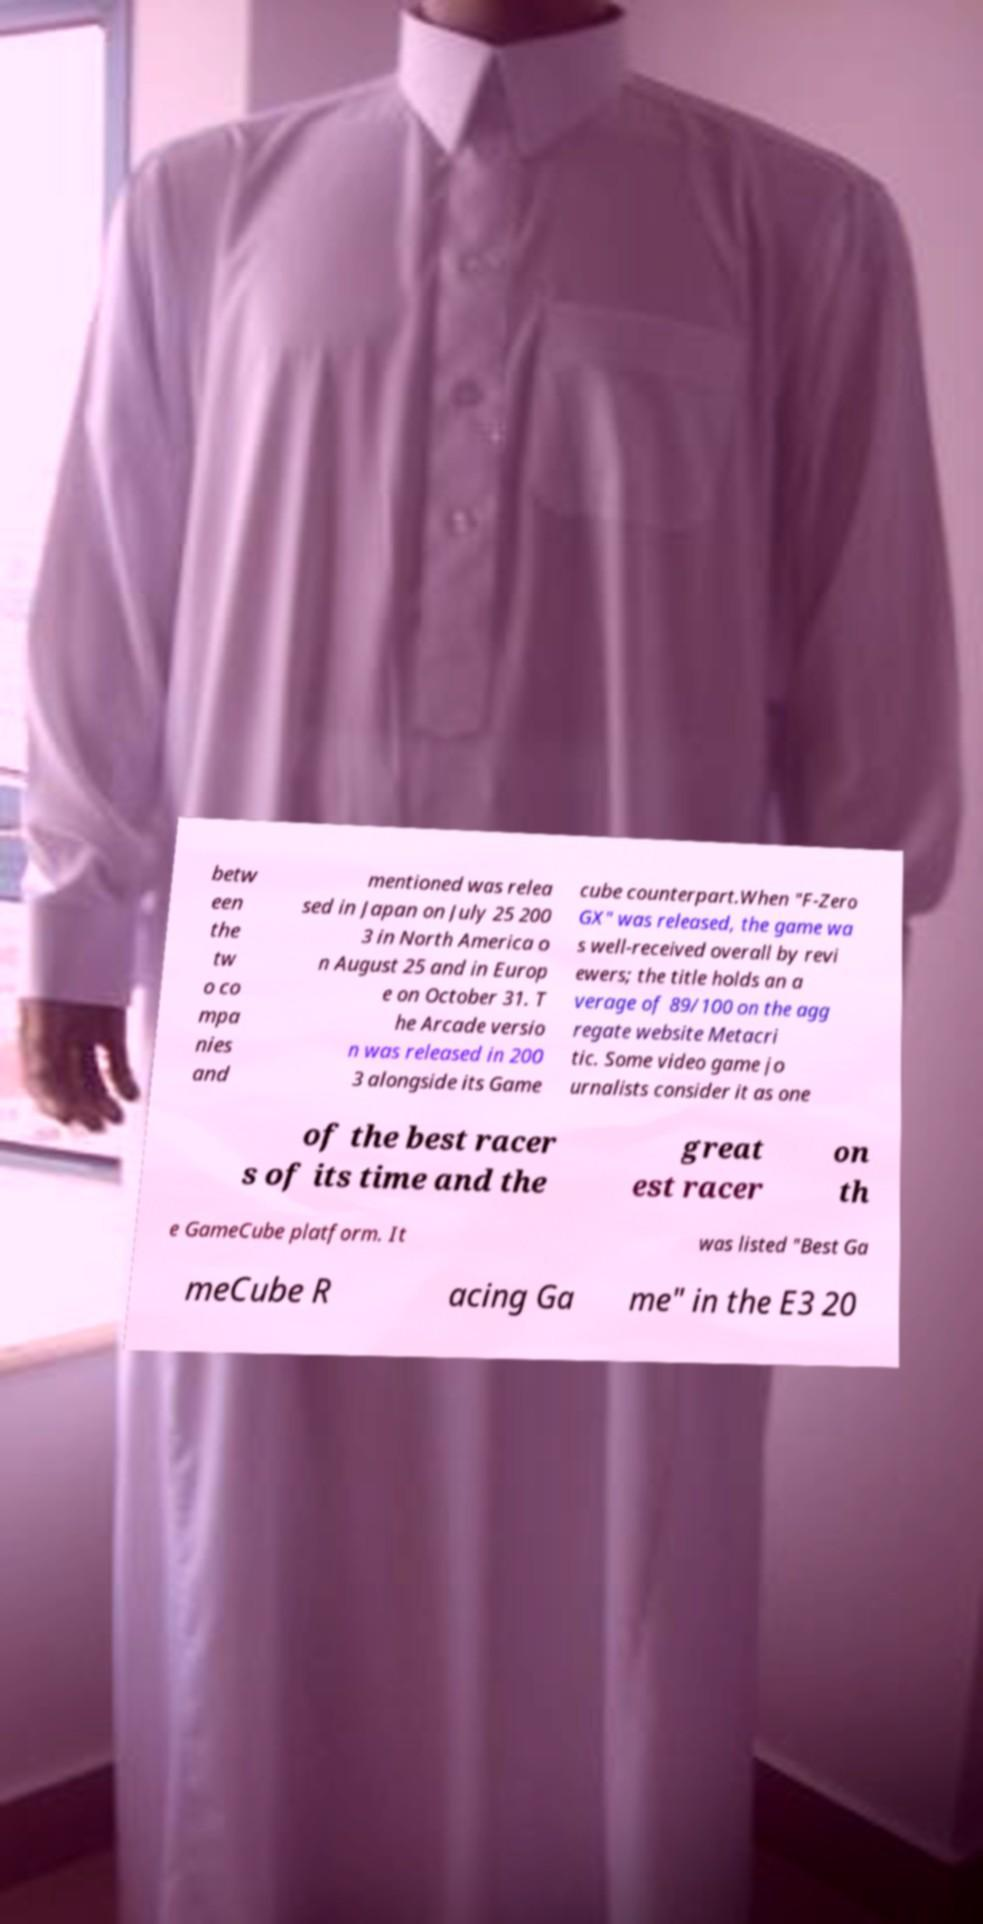I need the written content from this picture converted into text. Can you do that? betw een the tw o co mpa nies and mentioned was relea sed in Japan on July 25 200 3 in North America o n August 25 and in Europ e on October 31. T he Arcade versio n was released in 200 3 alongside its Game cube counterpart.When "F-Zero GX" was released, the game wa s well-received overall by revi ewers; the title holds an a verage of 89/100 on the agg regate website Metacri tic. Some video game jo urnalists consider it as one of the best racer s of its time and the great est racer on th e GameCube platform. It was listed "Best Ga meCube R acing Ga me" in the E3 20 